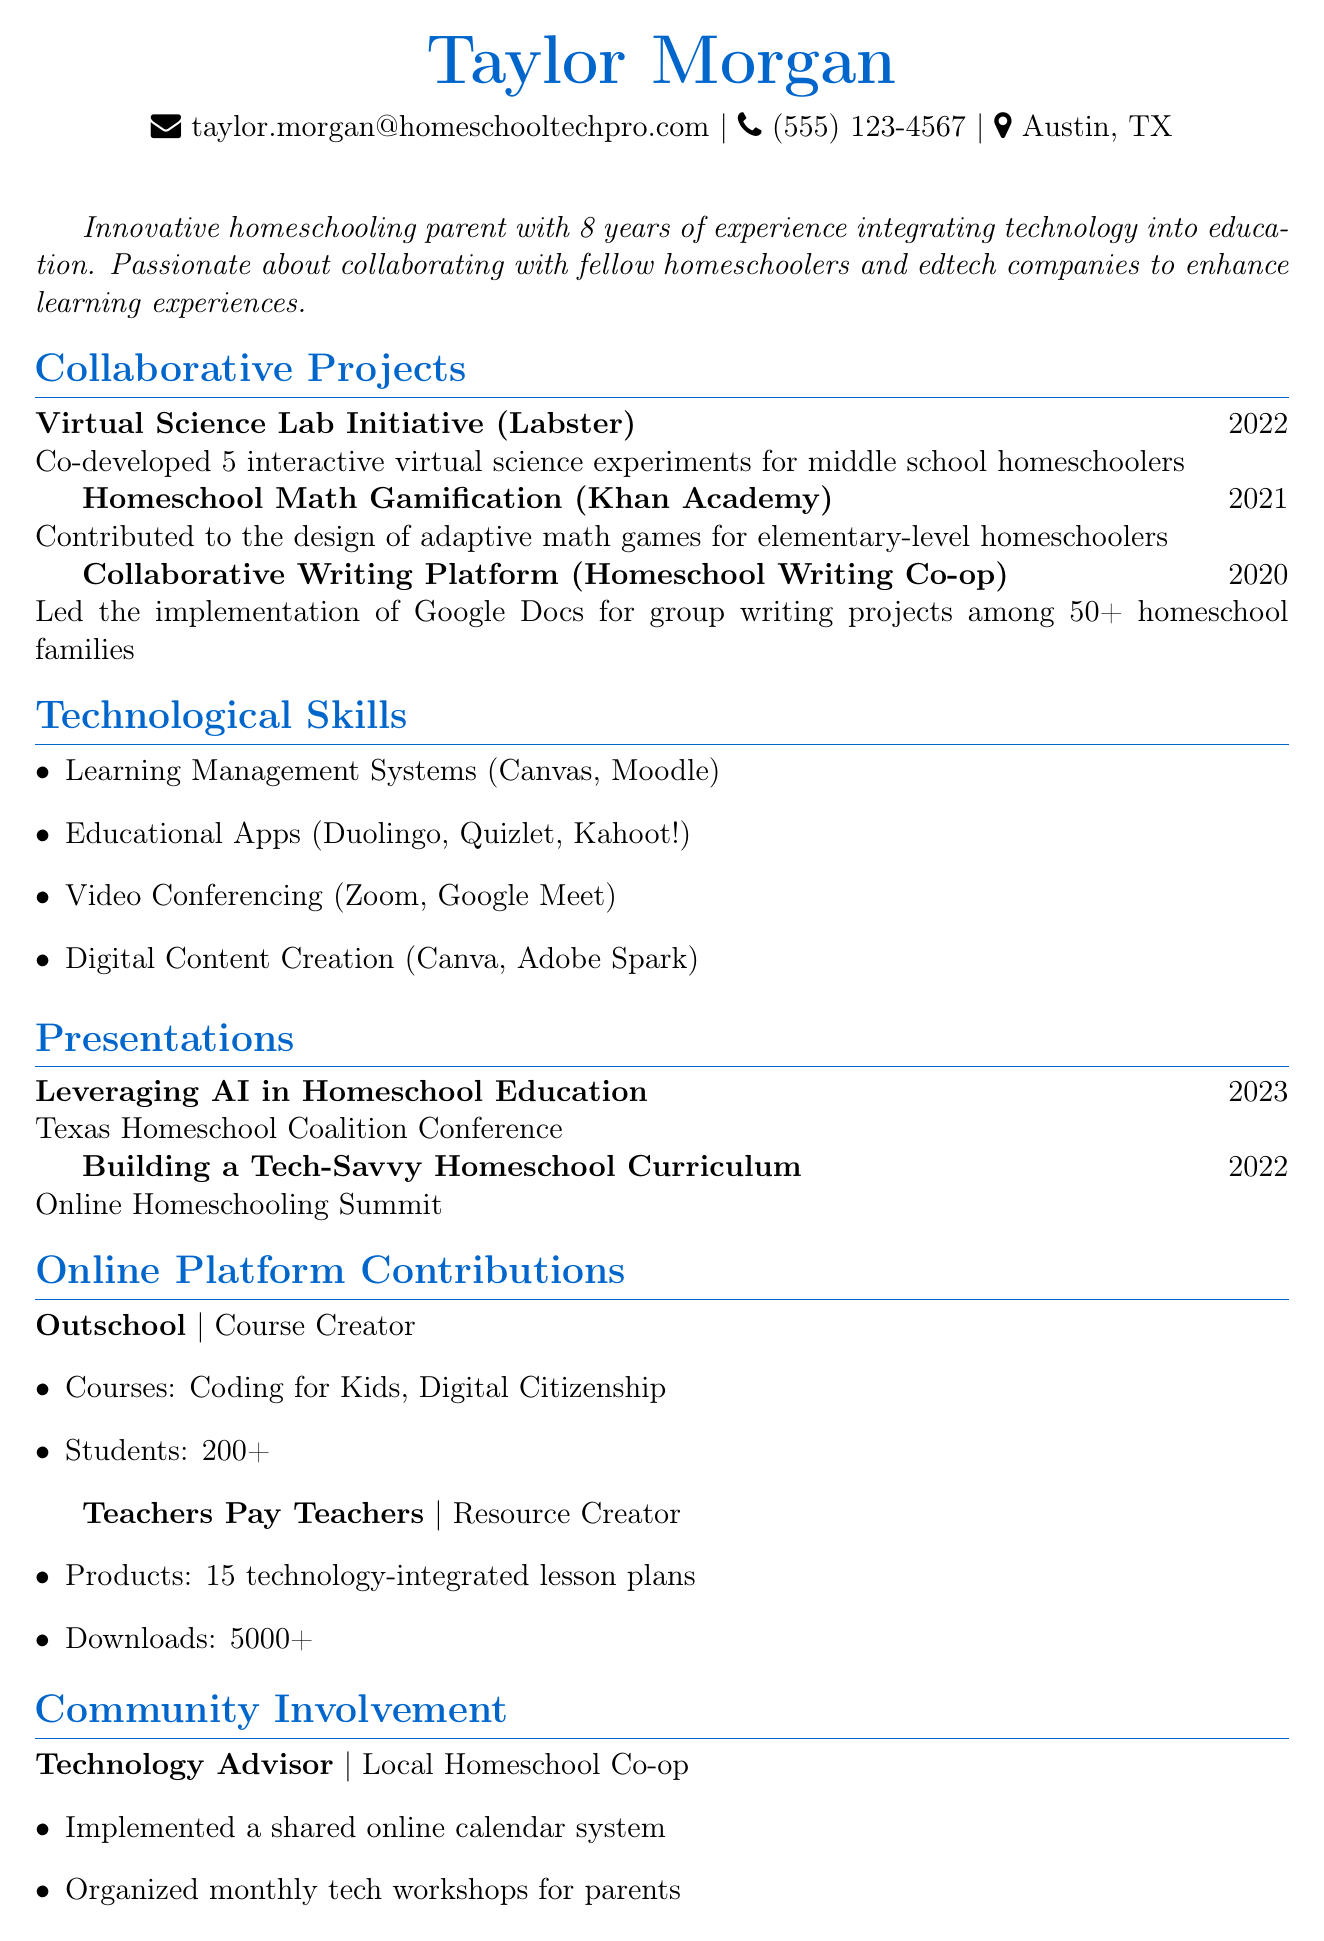what is the name of the individual in the CV? The document presents the name of the individual at the top as a header.
Answer: Taylor Morgan how many years of experience does Taylor have in homeschooling? The summary section states the total years of experience in homeschooling education.
Answer: 8 years which company partnered with Taylor for the Virtual Science Lab Initiative? This information is listed under the collaborative projects section.
Answer: Labster how many interactive virtual science experiments were co-developed for middle school homeschoolers? The description of the Virtual Science Lab Initiative specifies the number of experiments created.
Answer: 5 what role does Taylor have in the Local Homeschool Co-op? This title is mentioned in the community involvement section of the CV.
Answer: Technology Advisor what technology was used to lead the implementation of collaborative writing projects? This information can be found in the description of a collaborative project stated in the document.
Answer: Google Docs how many courses has Taylor created on Outschool? The online platform contributions section indicates the number of courses created.
Answer: 2 what year was the presentation on AI in Homeschool Education given? The presentations section details the year for each listed presentation.
Answer: 2023 how many technology-integrated lesson plans has Taylor created for Teachers Pay Teachers? This figure is highlighted under the online platform contributions section.
Answer: 15 